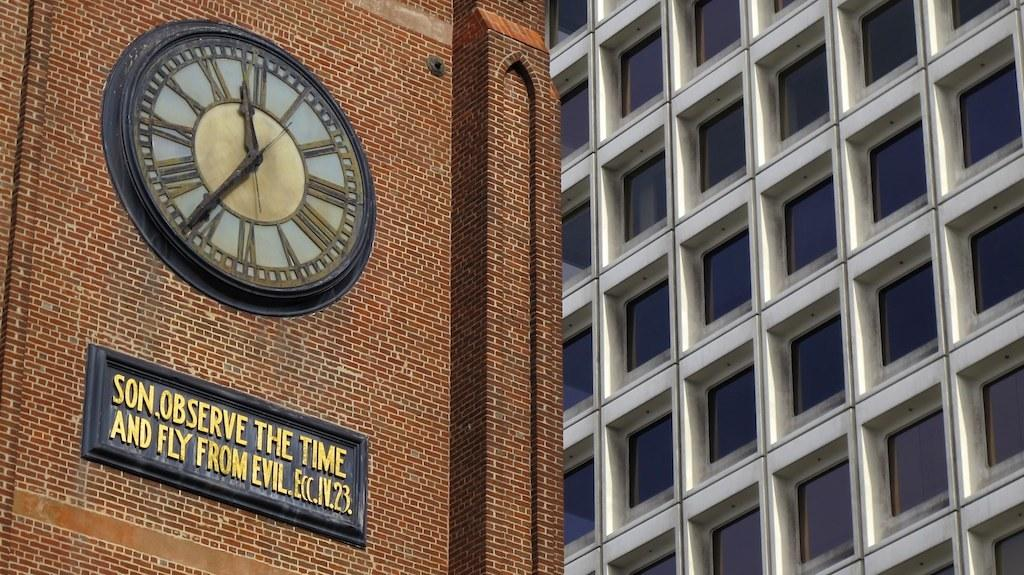<image>
Create a compact narrative representing the image presented. A plack beneath a clock reads "Son, observe the time and fly from evil" 